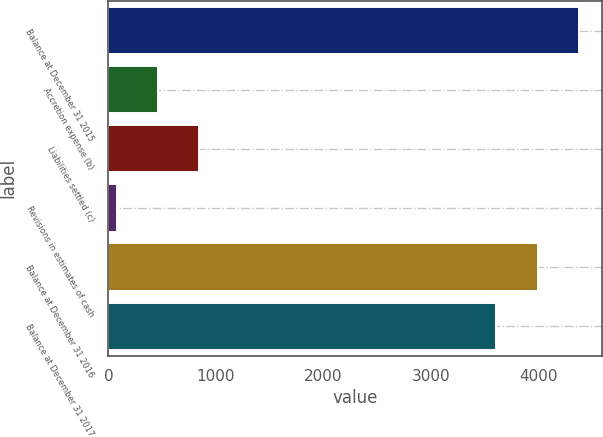<chart> <loc_0><loc_0><loc_500><loc_500><bar_chart><fcel>Balance at December 31 2015<fcel>Accretion expense (b)<fcel>Liabilities settled (c)<fcel>Revisions in estimates of cash<fcel>Balance at December 31 2016<fcel>Balance at December 31 2017<nl><fcel>4378.2<fcel>461.1<fcel>845.2<fcel>77<fcel>3994.1<fcel>3610<nl></chart> 